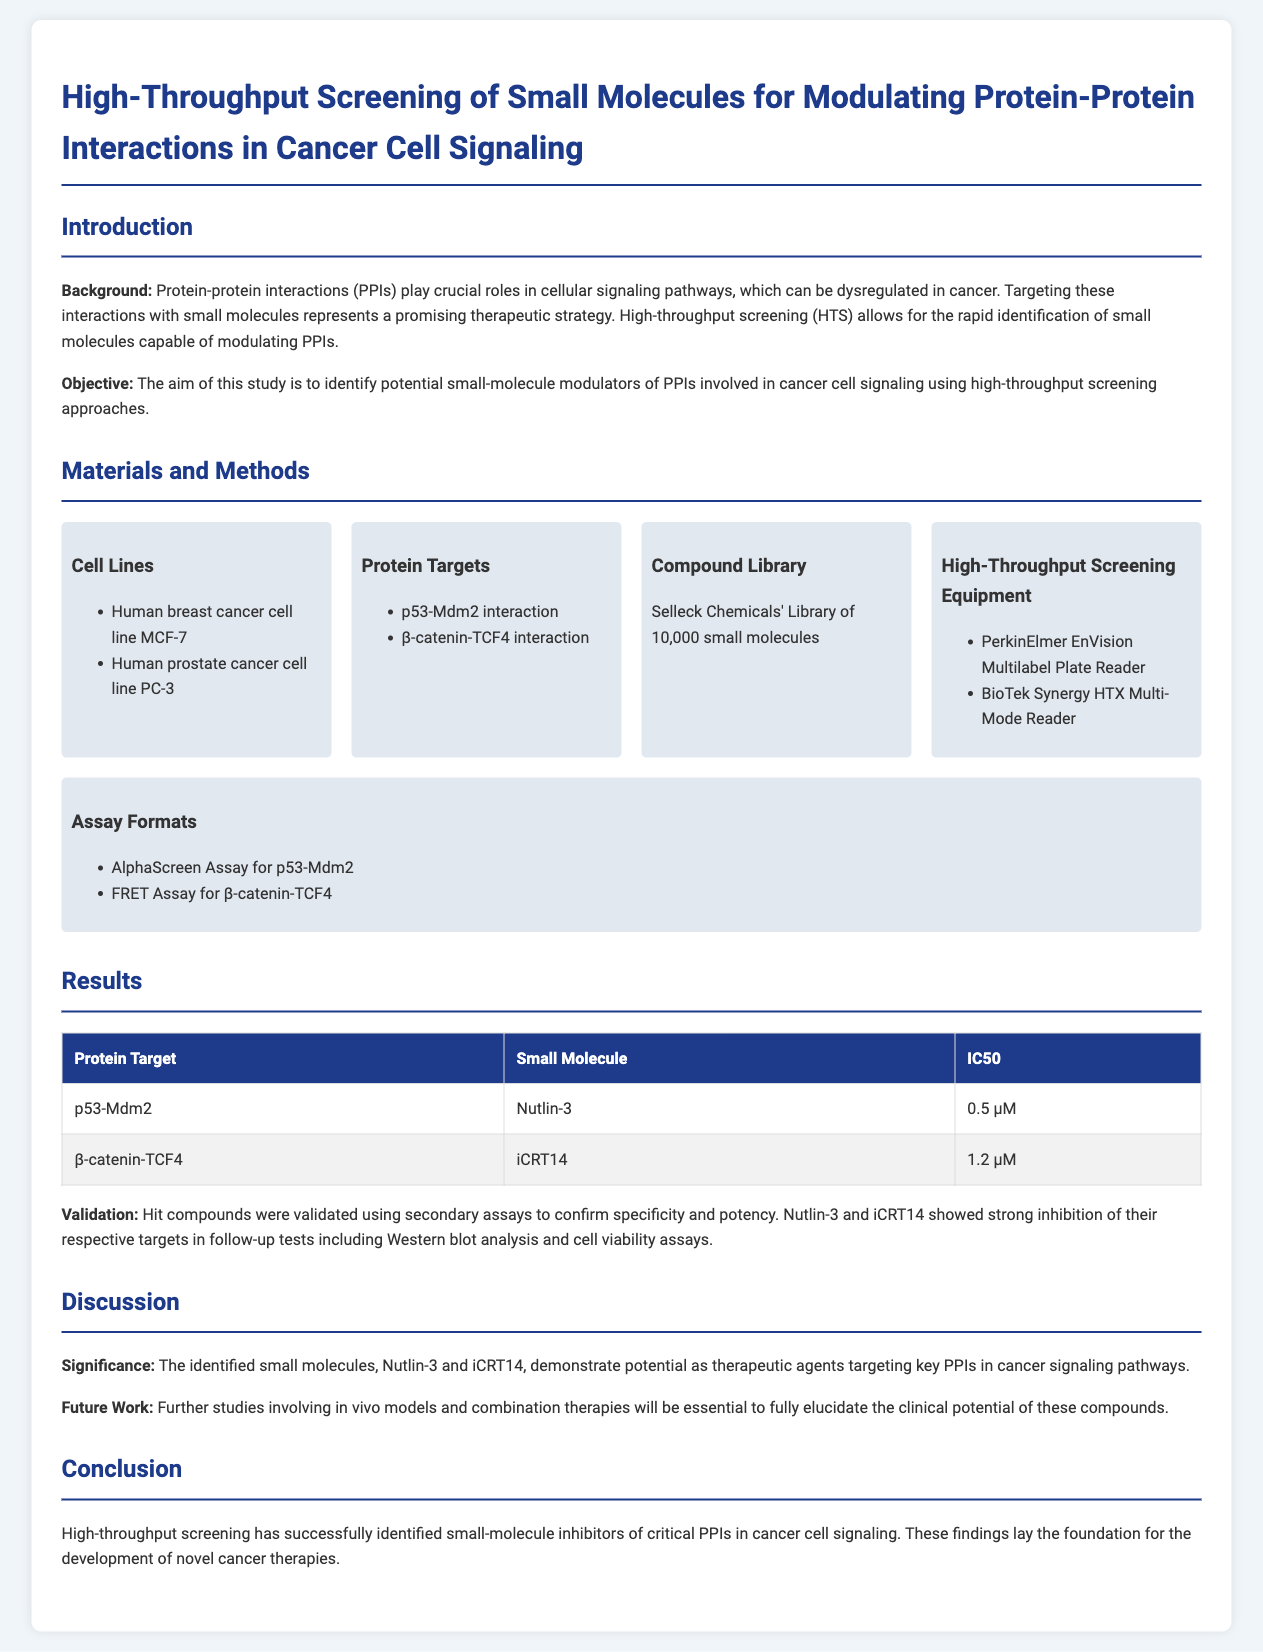What is the title of the report? The title of the report is explicitly stated at the beginning of the document.
Answer: High-Throughput Screening of Small Molecules for Modulating Protein-Protein Interactions in Cancer Cell Signaling What are the two protein targets studied? The document lists the protein targets involved in the study.
Answer: p53-Mdm2 interaction, β-catenin-TCF4 interaction What is the IC50 value for Nutlin-3? The IC50 value for Nutlin-3 is provided in the results section.
Answer: 0.5 µM What are the two cancer cell lines used? The cell lines used in the experiments are listed in the materials section.
Answer: MCF-7, PC-3 What assay was used for the p53-Mdm2 interaction? The document specifies the assay format used for p53-Mdm2.
Answer: AlphaScreen Assay What secondary assays were performed for validation? The document states the types of validation assays performed to confirm specificity and potency.
Answer: Western blot analysis and cell viability assays What is the objective of the study? The objective of the study is stated in the introduction section.
Answer: Identify potential small-molecule modulators of PPIs involved in cancer cell signaling What small molecule targets β-catenin-TCF4 interaction? The document lists the small molecules that inhibit specific protein interactions.
Answer: iCRT14 What is suggested for future work? Future work proposed in the discussion section outlines the next steps for research.
Answer: In vivo models and combination therapies 